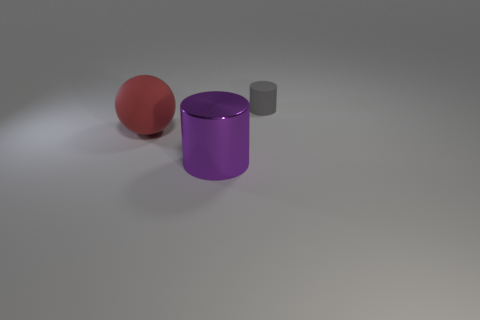There is a rubber object on the right side of the large matte sphere; is it the same shape as the big red matte object?
Keep it short and to the point. No. Is the number of purple metal cylinders less than the number of large yellow metallic balls?
Offer a very short reply. No. There is a sphere that is the same size as the purple metallic object; what is its material?
Offer a very short reply. Rubber. Does the large matte object have the same color as the object on the right side of the large purple cylinder?
Give a very brief answer. No. Is the number of small cylinders on the left side of the metallic cylinder less than the number of big metallic things?
Provide a succinct answer. Yes. How many purple metal objects are there?
Make the answer very short. 1. What shape is the thing in front of the rubber thing in front of the gray cylinder?
Ensure brevity in your answer.  Cylinder. What number of large objects are in front of the sphere?
Keep it short and to the point. 1. Does the purple cylinder have the same material as the cylinder behind the sphere?
Ensure brevity in your answer.  No. Is there a green block of the same size as the red object?
Offer a terse response. No. 